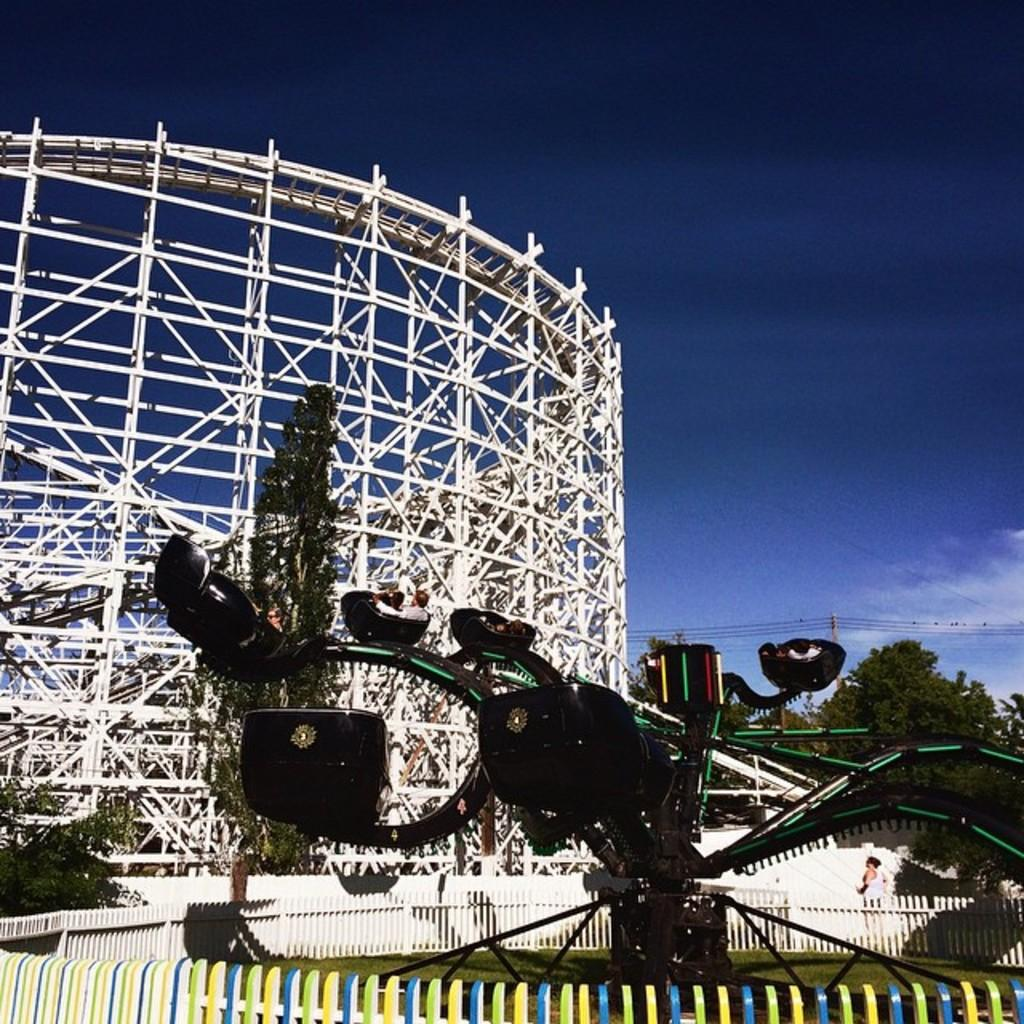What type of amusement park ride can be seen in the image? There are roller coasters in the image. What natural elements are present in the image? Trees are visible in the image. What type of infrastructure can be seen in the image? Wires and poles are present in the image. Who is present in the image? There are people in the image. What type of barrier is observable in the image? A fence is visible in the image. What can be seen in the background of the image? The sky with clouds is visible in the background of the image. What type of grain is being distributed by the copper machine in the image? There is no grain or copper machine present in the image. 